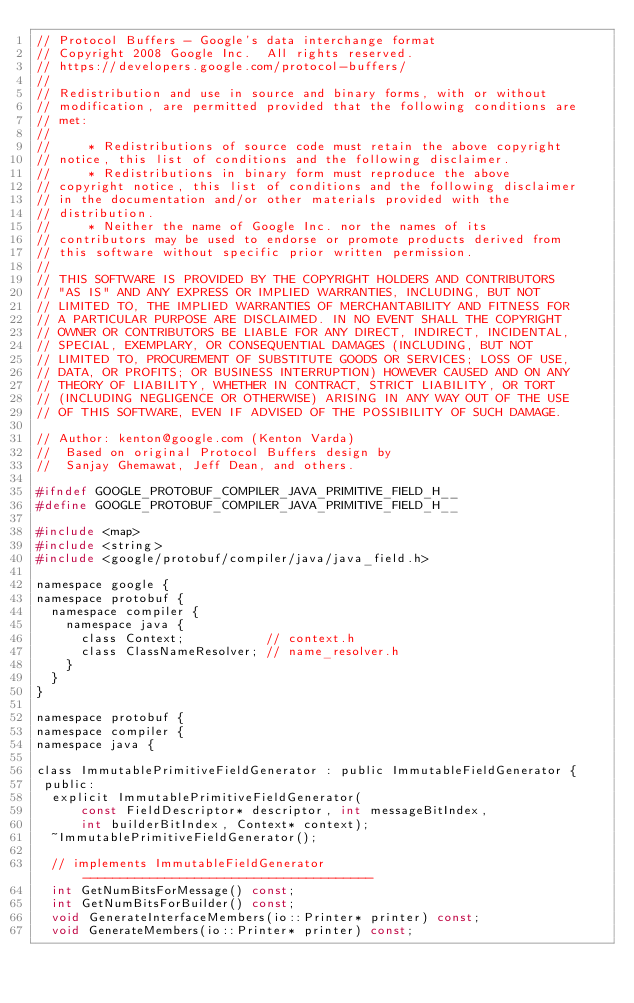Convert code to text. <code><loc_0><loc_0><loc_500><loc_500><_C_>// Protocol Buffers - Google's data interchange format
// Copyright 2008 Google Inc.  All rights reserved.
// https://developers.google.com/protocol-buffers/
//
// Redistribution and use in source and binary forms, with or without
// modification, are permitted provided that the following conditions are
// met:
//
//     * Redistributions of source code must retain the above copyright
// notice, this list of conditions and the following disclaimer.
//     * Redistributions in binary form must reproduce the above
// copyright notice, this list of conditions and the following disclaimer
// in the documentation and/or other materials provided with the
// distribution.
//     * Neither the name of Google Inc. nor the names of its
// contributors may be used to endorse or promote products derived from
// this software without specific prior written permission.
//
// THIS SOFTWARE IS PROVIDED BY THE COPYRIGHT HOLDERS AND CONTRIBUTORS
// "AS IS" AND ANY EXPRESS OR IMPLIED WARRANTIES, INCLUDING, BUT NOT
// LIMITED TO, THE IMPLIED WARRANTIES OF MERCHANTABILITY AND FITNESS FOR
// A PARTICULAR PURPOSE ARE DISCLAIMED. IN NO EVENT SHALL THE COPYRIGHT
// OWNER OR CONTRIBUTORS BE LIABLE FOR ANY DIRECT, INDIRECT, INCIDENTAL,
// SPECIAL, EXEMPLARY, OR CONSEQUENTIAL DAMAGES (INCLUDING, BUT NOT
// LIMITED TO, PROCUREMENT OF SUBSTITUTE GOODS OR SERVICES; LOSS OF USE,
// DATA, OR PROFITS; OR BUSINESS INTERRUPTION) HOWEVER CAUSED AND ON ANY
// THEORY OF LIABILITY, WHETHER IN CONTRACT, STRICT LIABILITY, OR TORT
// (INCLUDING NEGLIGENCE OR OTHERWISE) ARISING IN ANY WAY OUT OF THE USE
// OF THIS SOFTWARE, EVEN IF ADVISED OF THE POSSIBILITY OF SUCH DAMAGE.

// Author: kenton@google.com (Kenton Varda)
//  Based on original Protocol Buffers design by
//  Sanjay Ghemawat, Jeff Dean, and others.

#ifndef GOOGLE_PROTOBUF_COMPILER_JAVA_PRIMITIVE_FIELD_H__
#define GOOGLE_PROTOBUF_COMPILER_JAVA_PRIMITIVE_FIELD_H__

#include <map>
#include <string>
#include <google/protobuf/compiler/java/java_field.h>

namespace google {
namespace protobuf {
  namespace compiler {
    namespace java {
      class Context;           // context.h
      class ClassNameResolver; // name_resolver.h
    }
  }
}

namespace protobuf {
namespace compiler {
namespace java {

class ImmutablePrimitiveFieldGenerator : public ImmutableFieldGenerator {
 public:
  explicit ImmutablePrimitiveFieldGenerator(
      const FieldDescriptor* descriptor, int messageBitIndex,
      int builderBitIndex, Context* context);
  ~ImmutablePrimitiveFieldGenerator();

  // implements ImmutableFieldGenerator ---------------------------------------
  int GetNumBitsForMessage() const;
  int GetNumBitsForBuilder() const;
  void GenerateInterfaceMembers(io::Printer* printer) const;
  void GenerateMembers(io::Printer* printer) const;</code> 